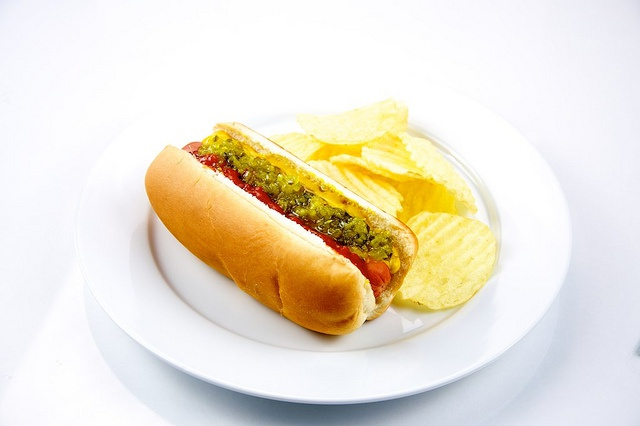Describe the objects in this image and their specific colors. I can see a hot dog in lavender, orange, red, and khaki tones in this image. 